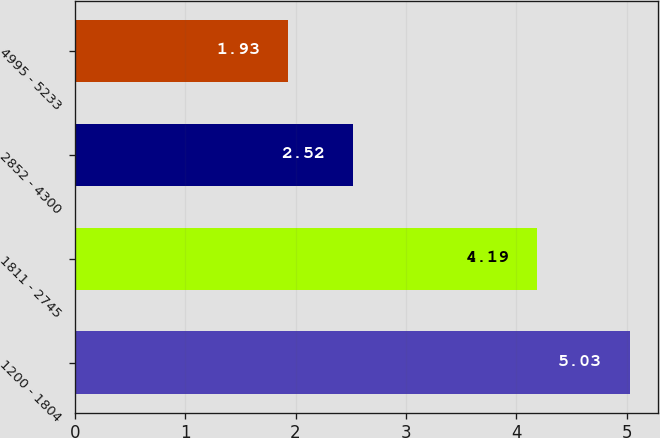Convert chart. <chart><loc_0><loc_0><loc_500><loc_500><bar_chart><fcel>1200 - 1804<fcel>1811 - 2745<fcel>2852 - 4300<fcel>4995 - 5233<nl><fcel>5.03<fcel>4.19<fcel>2.52<fcel>1.93<nl></chart> 